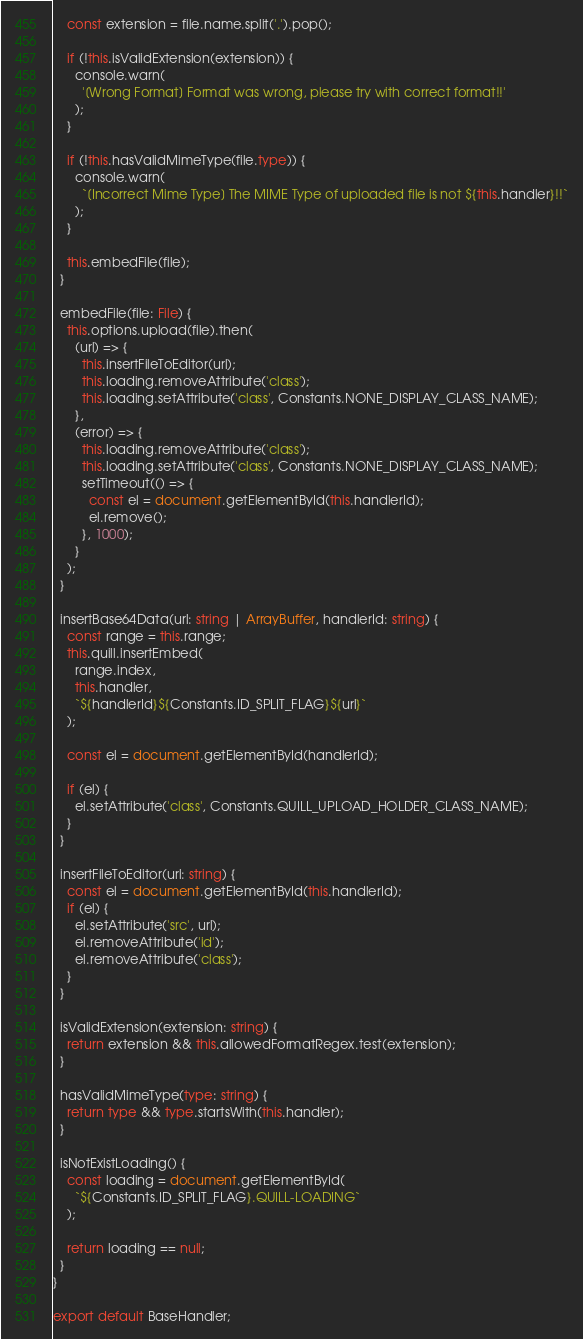<code> <loc_0><loc_0><loc_500><loc_500><_TypeScript_>
    const extension = file.name.split('.').pop();

    if (!this.isValidExtension(extension)) {
      console.warn(
        '[Wrong Format] Format was wrong, please try with correct format!!'
      );
    }

    if (!this.hasValidMimeType(file.type)) {
      console.warn(
        `[Incorrect Mime Type] The MIME Type of uploaded file is not ${this.handler}!!`
      );
    }

    this.embedFile(file);
  }

  embedFile(file: File) {
    this.options.upload(file).then(
      (url) => {
        this.insertFileToEditor(url);
        this.loading.removeAttribute('class');
        this.loading.setAttribute('class', Constants.NONE_DISPLAY_CLASS_NAME);
      },
      (error) => {
        this.loading.removeAttribute('class');
        this.loading.setAttribute('class', Constants.NONE_DISPLAY_CLASS_NAME);
        setTimeout(() => {
          const el = document.getElementById(this.handlerId);
          el.remove();
        }, 1000);
      }
    );
  }

  insertBase64Data(url: string | ArrayBuffer, handlerId: string) {
    const range = this.range;
    this.quill.insertEmbed(
      range.index,
      this.handler,
      `${handlerId}${Constants.ID_SPLIT_FLAG}${url}`
    );

    const el = document.getElementById(handlerId);

    if (el) {
      el.setAttribute('class', Constants.QUILL_UPLOAD_HOLDER_CLASS_NAME);
    }
  }

  insertFileToEditor(url: string) {
    const el = document.getElementById(this.handlerId);
    if (el) {
      el.setAttribute('src', url);
      el.removeAttribute('id');
      el.removeAttribute('class');
    }
  }

  isValidExtension(extension: string) {
    return extension && this.allowedFormatRegex.test(extension);
  }

  hasValidMimeType(type: string) {
    return type && type.startsWith(this.handler);
  }

  isNotExistLoading() {
    const loading = document.getElementById(
      `${Constants.ID_SPLIT_FLAG}.QUILL-LOADING`
    );

    return loading == null;
  }
}

export default BaseHandler;
</code> 